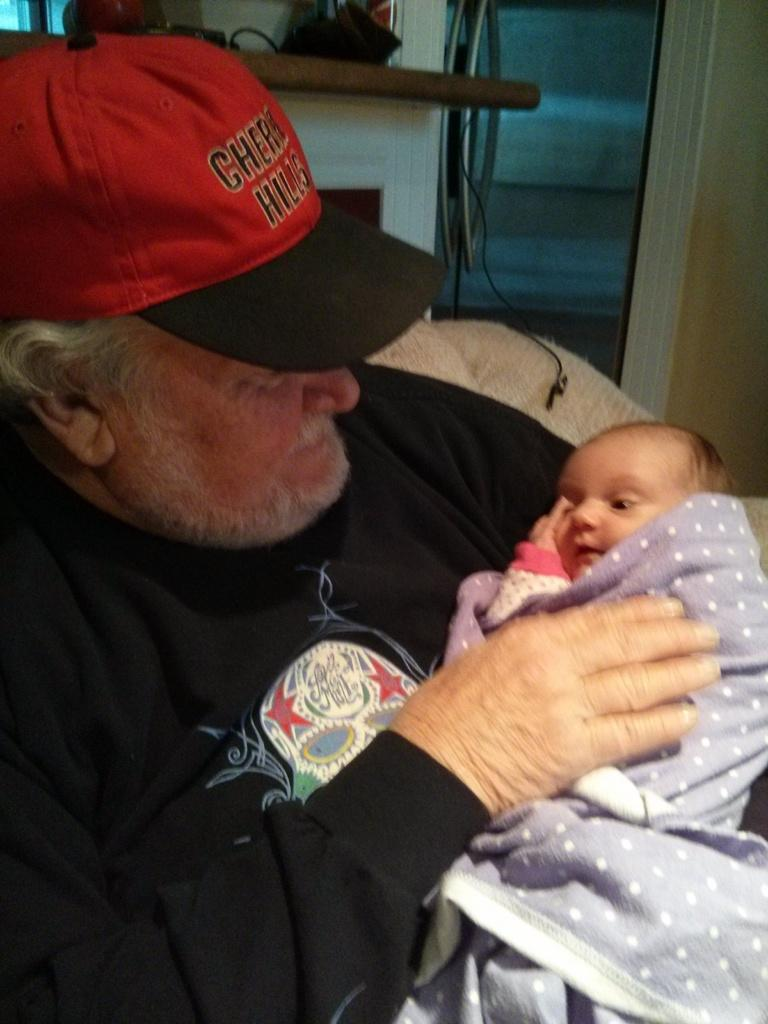<image>
Offer a succinct explanation of the picture presented. The man holding the baby is wearing a Cherry Hills hat. 